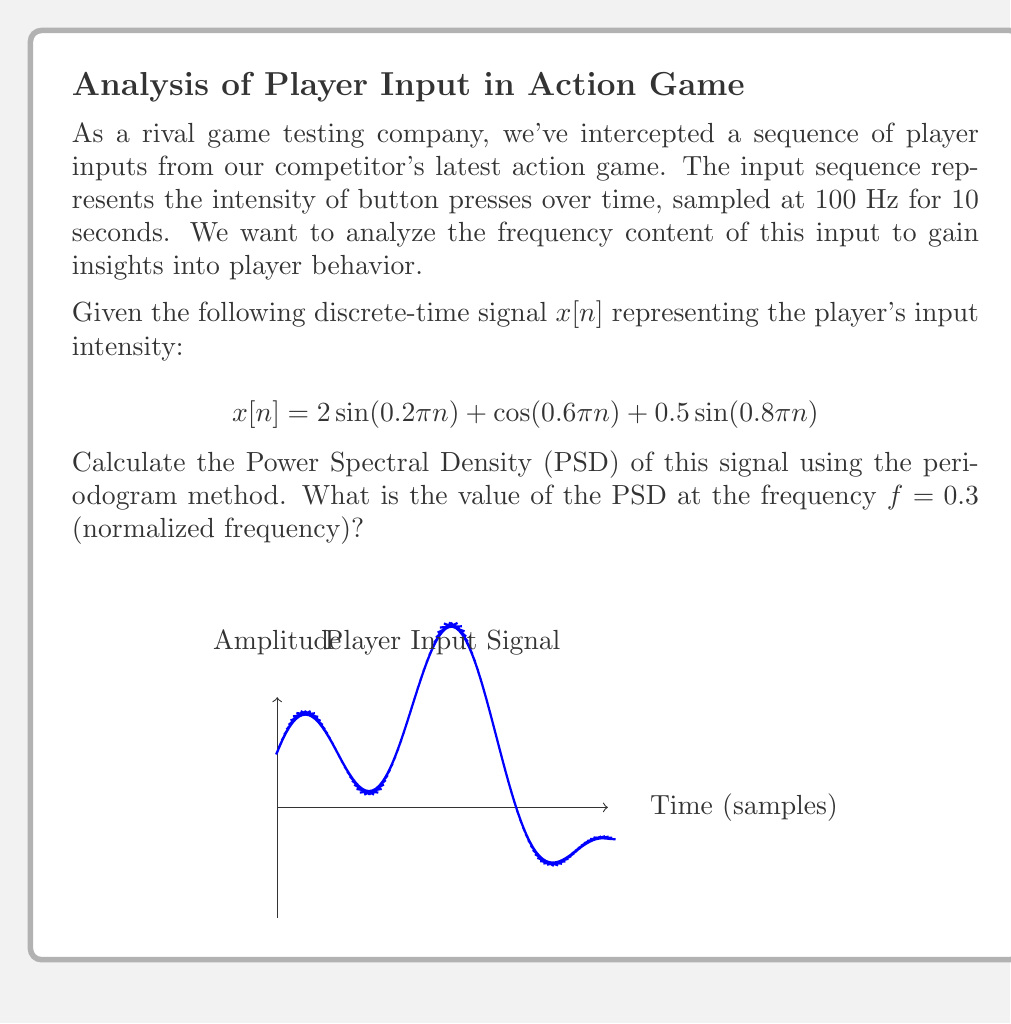What is the answer to this math problem? To solve this problem, we'll follow these steps:

1) First, we need to compute the Discrete Fourier Transform (DFT) of the signal. For a sequence of length N, the DFT is given by:

   $$X[k] = \sum_{n=0}^{N-1} x[n]e^{-j2\pi kn/N}$$

2) The periodogram estimate of the PSD is then given by:

   $$P_{xx}(f) = \frac{1}{N}|X[k]|^2$$

   where $f = k/N$ is the normalized frequency.

3) For our signal, we have 1000 samples (10 seconds at 100 Hz). Let's compute the DFT:

   $$X[k] = \sum_{n=0}^{999} (2\sin(0.2\pi n) + \cos(0.6\pi n) + 0.5\sin(0.8\pi n))e^{-j2\pi kn/1000}$$

4) This sum can be simplified using the properties of DFT:
   - A sinusoid at frequency $f_0$ will have peaks in its DFT at $k = \pm f_0N$.
   - The DFT of $\sin(2\pi f_0 n)$ will have peaks at $k = \pm f_0N$ with magnitude $N/2$.
   - The DFT of $\cos(2\pi f_0 n)$ will have peaks at $k = \pm f_0N$ with magnitude $N/2$.

5) Therefore, our DFT will have peaks at:
   - $k = \pm 100$ (for $f_0 = 0.1$) with magnitude $1000$
   - $k = \pm 300$ (for $f_0 = 0.3$) with magnitude $500$
   - $k = \pm 400$ (for $f_0 = 0.4$) with magnitude $250$

6) At $f = 0.3$ (or $k = 300$), we have:

   $$|X[300]|^2 = 500^2 = 250000$$

7) The PSD at this frequency is:

   $$P_{xx}(0.3) = \frac{1}{1000}|X[300]|^2 = \frac{250000}{1000} = 250$$
Answer: 250 